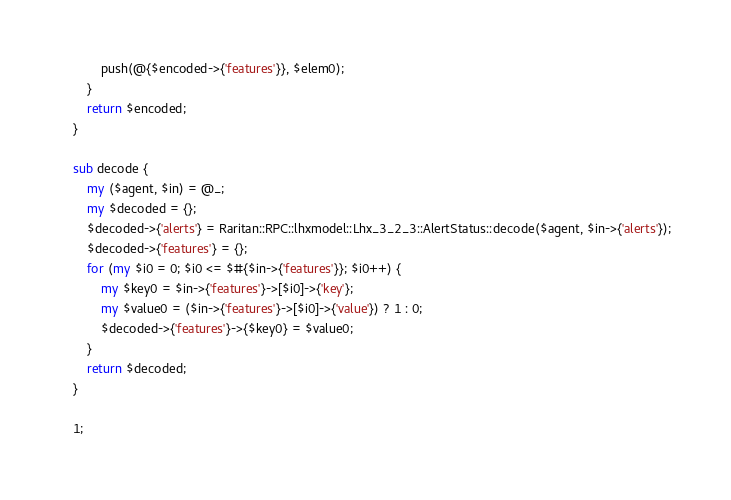<code> <loc_0><loc_0><loc_500><loc_500><_Perl_>        push(@{$encoded->{'features'}}, $elem0);
    }
    return $encoded;
}

sub decode {
    my ($agent, $in) = @_;
    my $decoded = {};
    $decoded->{'alerts'} = Raritan::RPC::lhxmodel::Lhx_3_2_3::AlertStatus::decode($agent, $in->{'alerts'});
    $decoded->{'features'} = {};
    for (my $i0 = 0; $i0 <= $#{$in->{'features'}}; $i0++) {
        my $key0 = $in->{'features'}->[$i0]->{'key'};
        my $value0 = ($in->{'features'}->[$i0]->{'value'}) ? 1 : 0;
        $decoded->{'features'}->{$key0} = $value0;
    }
    return $decoded;
}

1;
</code> 